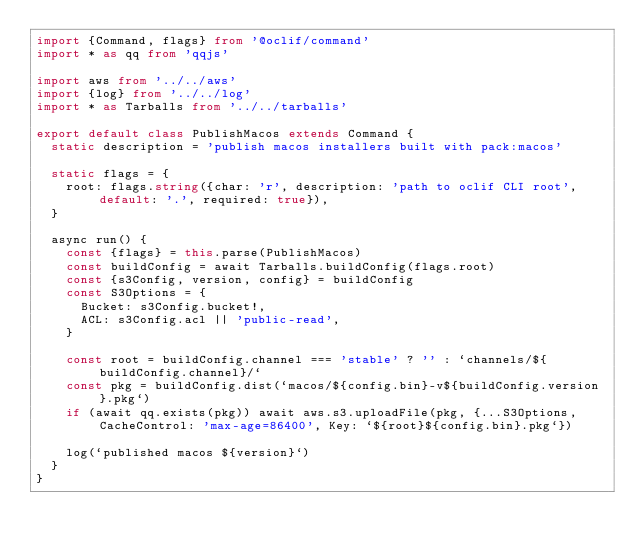<code> <loc_0><loc_0><loc_500><loc_500><_TypeScript_>import {Command, flags} from '@oclif/command'
import * as qq from 'qqjs'

import aws from '../../aws'
import {log} from '../../log'
import * as Tarballs from '../../tarballs'

export default class PublishMacos extends Command {
  static description = 'publish macos installers built with pack:macos'

  static flags = {
    root: flags.string({char: 'r', description: 'path to oclif CLI root', default: '.', required: true}),
  }

  async run() {
    const {flags} = this.parse(PublishMacos)
    const buildConfig = await Tarballs.buildConfig(flags.root)
    const {s3Config, version, config} = buildConfig
    const S3Options = {
      Bucket: s3Config.bucket!,
      ACL: s3Config.acl || 'public-read',
    }

    const root = buildConfig.channel === 'stable' ? '' : `channels/${buildConfig.channel}/`
    const pkg = buildConfig.dist(`macos/${config.bin}-v${buildConfig.version}.pkg`)
    if (await qq.exists(pkg)) await aws.s3.uploadFile(pkg, {...S3Options, CacheControl: 'max-age=86400', Key: `${root}${config.bin}.pkg`})

    log(`published macos ${version}`)
  }
}
</code> 